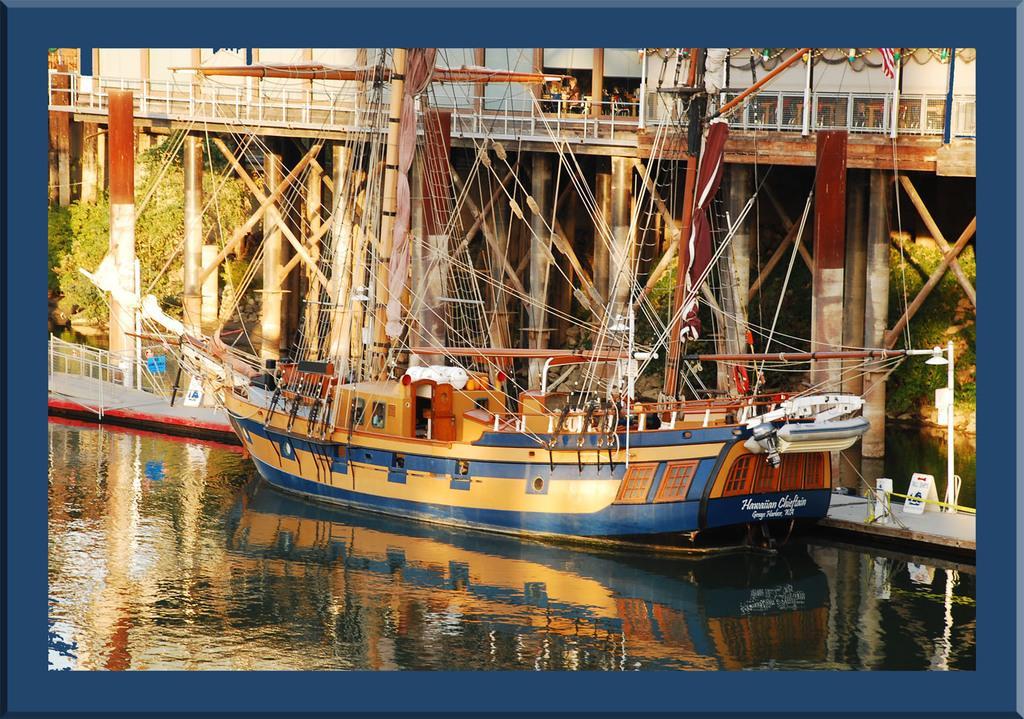In one or two sentences, can you explain what this image depicts? In this image there is a boat on the water body. In the background there is a bridge and trees. 